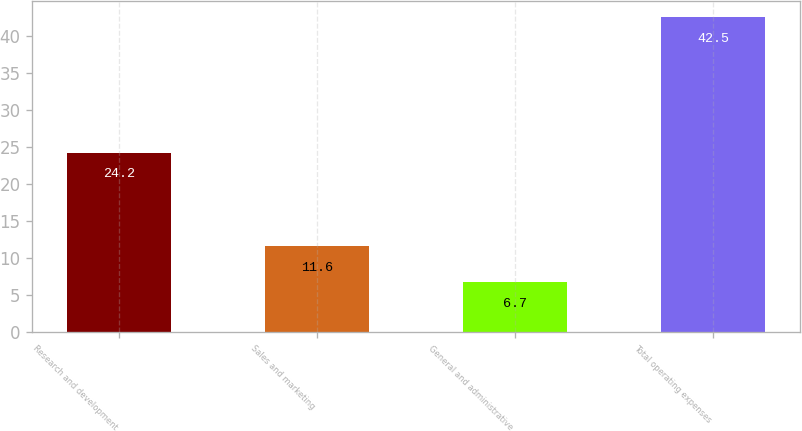Convert chart. <chart><loc_0><loc_0><loc_500><loc_500><bar_chart><fcel>Research and development<fcel>Sales and marketing<fcel>General and administrative<fcel>Total operating expenses<nl><fcel>24.2<fcel>11.6<fcel>6.7<fcel>42.5<nl></chart> 